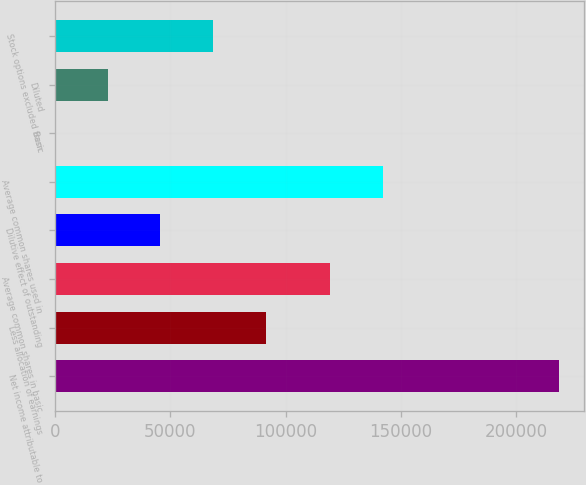Convert chart to OTSL. <chart><loc_0><loc_0><loc_500><loc_500><bar_chart><fcel>Net income attributable to<fcel>Less allocation of earnings<fcel>Average common shares in basic<fcel>Dilutive effect of outstanding<fcel>Average common shares used in<fcel>Basic<fcel>Diluted<fcel>Stock options excluded from<nl><fcel>218676<fcel>91314.3<fcel>119335<fcel>45658.1<fcel>142163<fcel>1.83<fcel>22830<fcel>68486.2<nl></chart> 